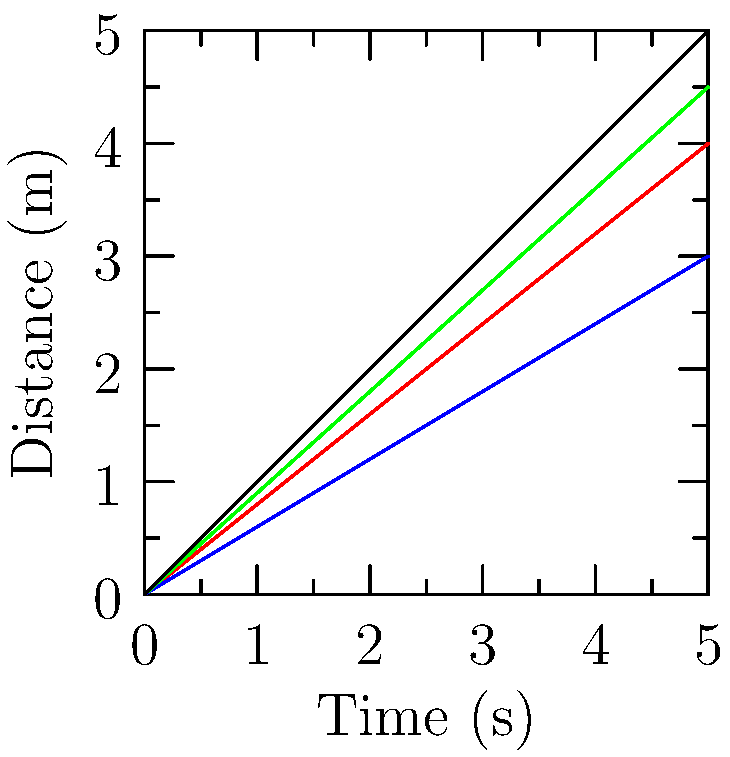Based on the graph showing the distance covered over time for different swimming strokes, which stroke demonstrates the highest biomechanical efficiency in terms of distance covered per unit time? To determine the biomechanical efficiency of each swimming stroke, we need to analyze the distance covered over time for each stroke:

1. Observe the slopes of each line in the graph. The steeper the slope, the more distance is covered in less time, indicating higher efficiency.

2. Compare the strokes:
   - Freestyle (black line): Covers 5m in 5s
   - Butterfly (red line): Covers 4m in 5s
   - Backstroke (green line): Covers 4.5m in 5s
   - Breaststroke (blue line): Covers 3m in 5s

3. Calculate the speed (distance/time) for each stroke:
   - Freestyle: $\frac{5m}{5s} = 1 m/s$
   - Butterfly: $\frac{4m}{5s} = 0.8 m/s$
   - Backstroke: $\frac{4.5m}{5s} = 0.9 m/s$
   - Breaststroke: $\frac{3m}{5s} = 0.6 m/s$

4. The stroke with the highest speed (distance covered per unit time) is the most biomechanically efficient.

5. Freestyle has the highest speed at 1 m/s, making it the most efficient stroke.

This analysis demonstrates how biomechanical efficiency in swimming can be quantified and compared, which is relevant to digitization technologies that might be used to track and analyze athletic performance.
Answer: Freestyle 